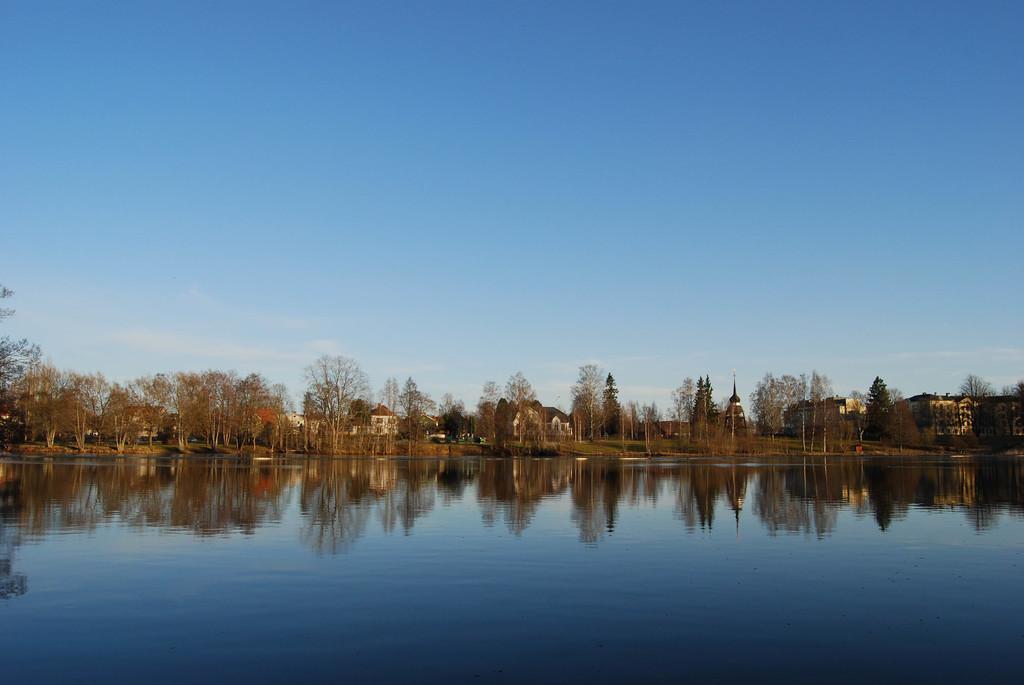How would you summarize this image in a sentence or two? In this image there is water in the middle. In the background there are houses and trees between them. At the top there is the sky. There are reflections on the water. 